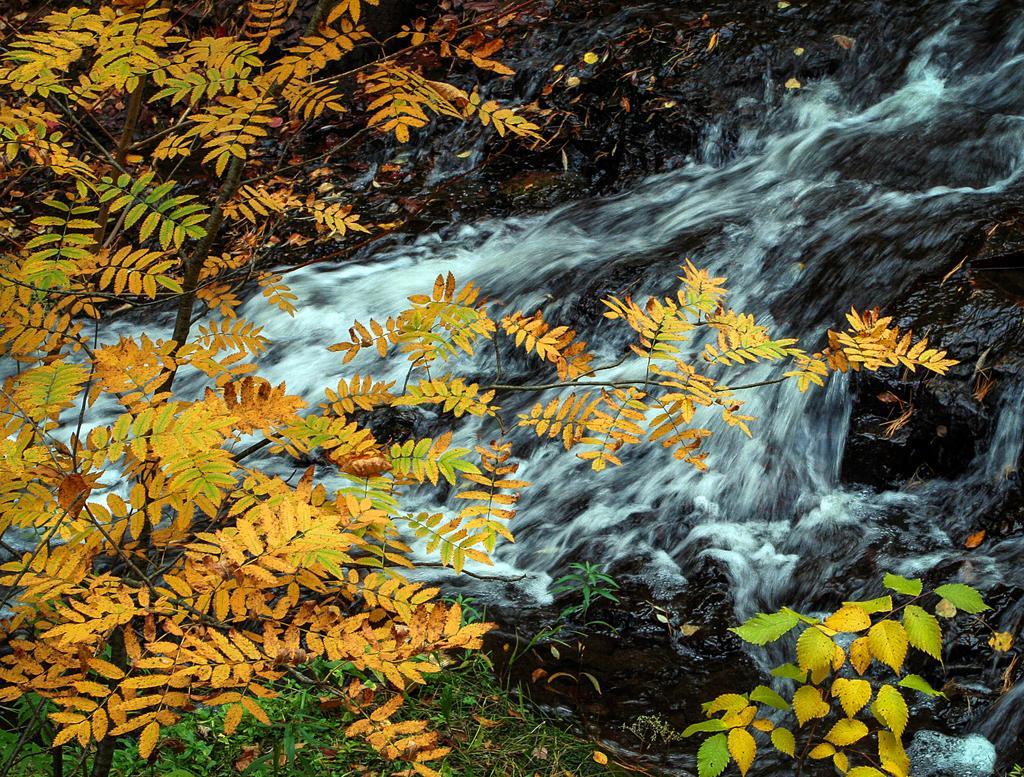Can you describe this image briefly? In this image I can see the trees. To the side I can see the water flowing from the rock. 